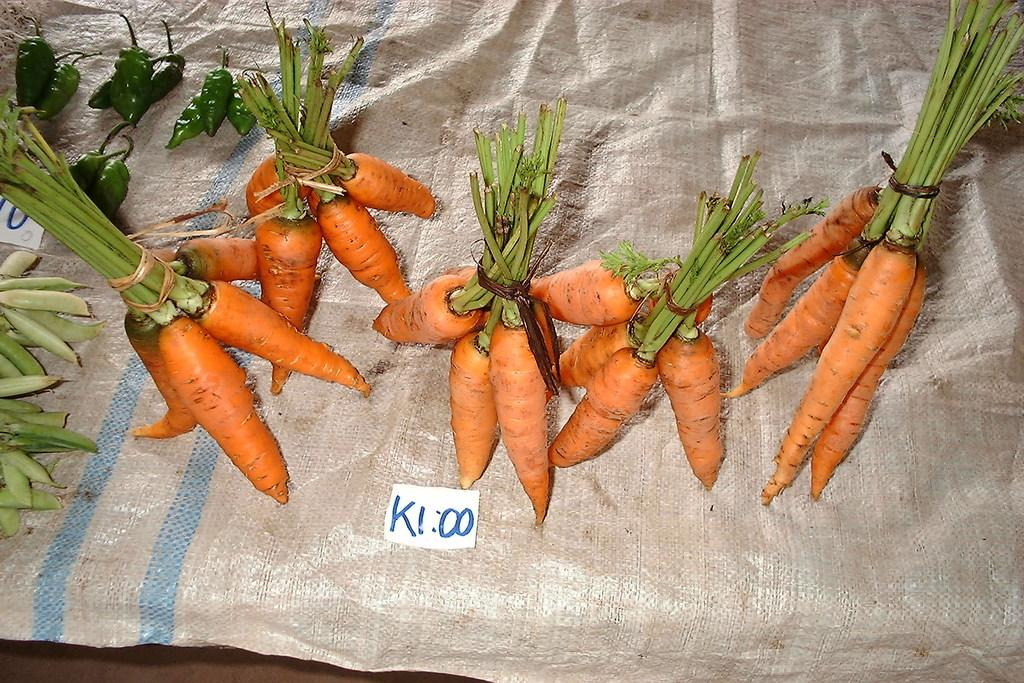What type of vegetables are in the middle of the image? There are carrots in the middle of the image. What can be found at the bottom of the image? There is text at the bottom of the image. What other vegetables are on the left side of the image? There are chillies and peas on the left side of the image. What type of metal can be seen in the image? There is no metal present in the image; it features vegetables and text. Is there any dirt visible in the image? There is no dirt visible in the image; it is a clean representation of vegetables and text. 